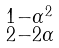<formula> <loc_0><loc_0><loc_500><loc_500>\begin{smallmatrix} 1 - \alpha ^ { 2 } \\ 2 - 2 \alpha \end{smallmatrix}</formula> 